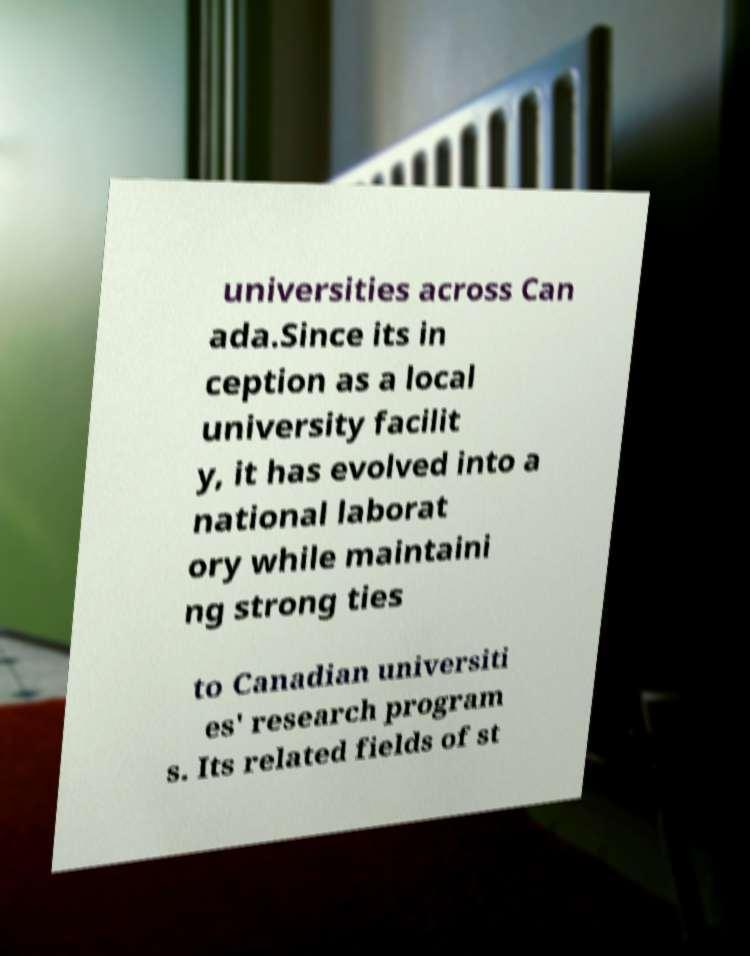For documentation purposes, I need the text within this image transcribed. Could you provide that? universities across Can ada.Since its in ception as a local university facilit y, it has evolved into a national laborat ory while maintaini ng strong ties to Canadian universiti es' research program s. Its related fields of st 